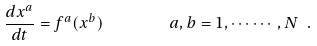<formula> <loc_0><loc_0><loc_500><loc_500>\frac { d x ^ { a } } { d t } = f ^ { a } ( x ^ { b } ) \ \, \quad \ \ a , b = 1 , \cdots \cdots , N \ .</formula> 